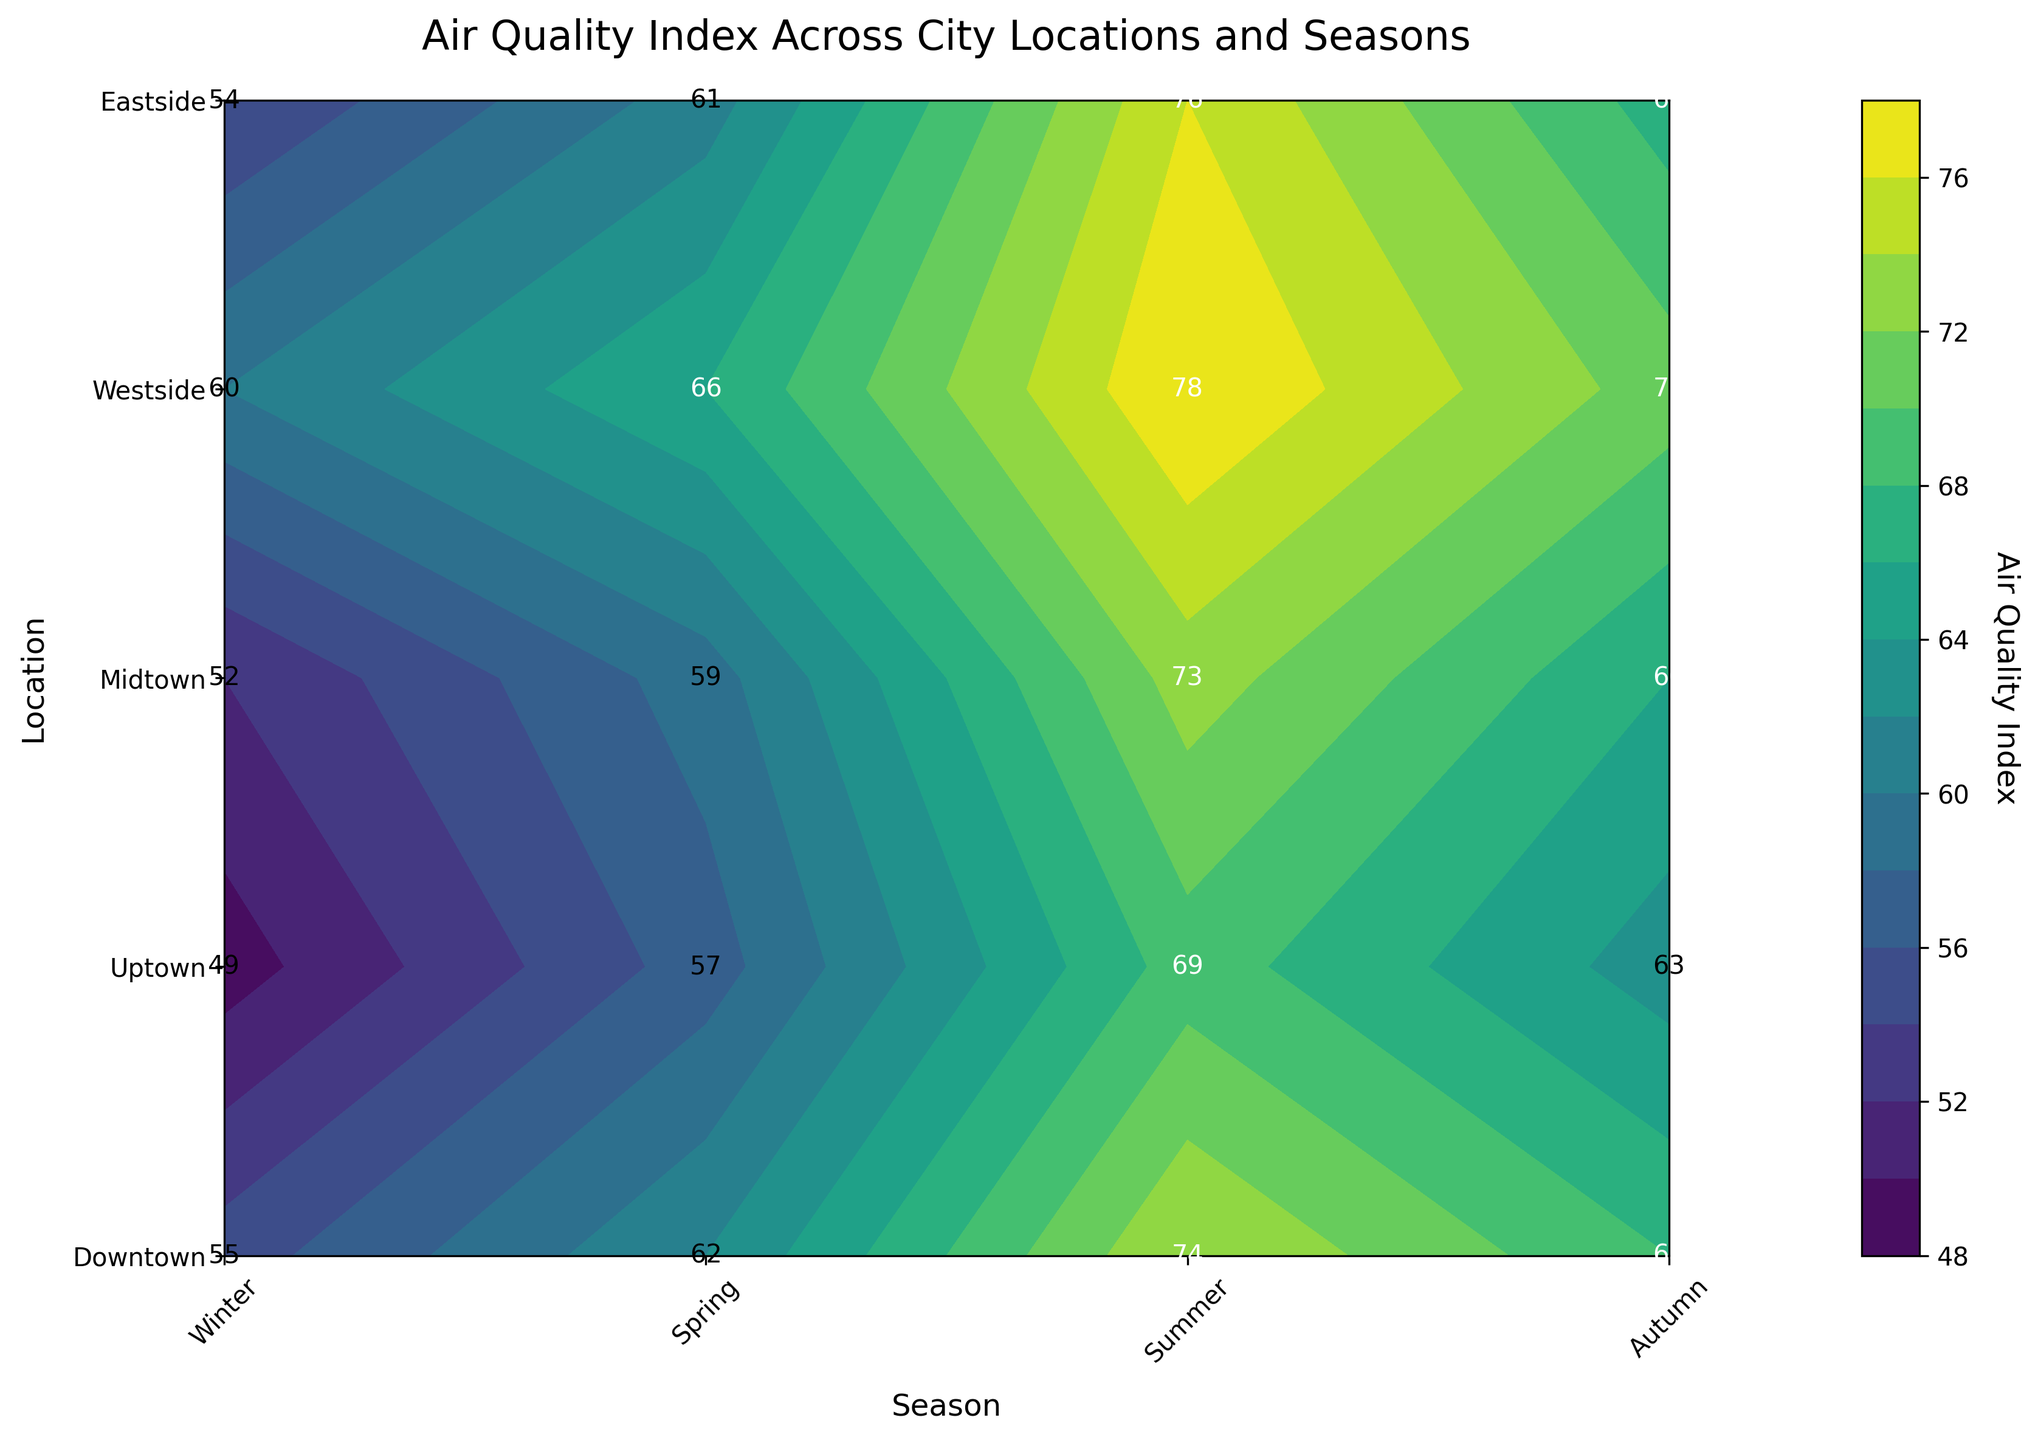What's the title of the plot? The title of the plot is displayed at the top center of the figure. It summarizes what the plot is about.
Answer: Air Quality Index Across City Locations and Seasons What does the y-axis represent? The y-axis labels indicate different parts of the city, so it represents various city locations.
Answer: Various city locations Which season has the highest AQI in Downtown? The AQI values are labeled within the contour plot. By scanning the values for Downtown, we find the highest value.
Answer: Summer What's the color range in the contour plot? The color range can be seen by looking at the gradient of colors used in the contour plot and the color bar on the side. It shows the range of AQIs.
Answer: From dark blue (lowest AQI) to yellow-green (highest AQI) What is the AQI difference between Winter and Summer in Westside? Locate the AQI values for Winter and Summer in Westside. Subtract the Winter value from the Summer value to get the difference.
Answer: 18 (78 - 60) Which location has the lowest AQI in Autumn? Check the AQI values for all locations in Autumn and find the one with the lowest value.
Answer: Uptown During which season does Eastside experience the maximum AQI? Observe the AQI values for Eastside across all seasons and identify the maximum value.
Answer: Summer In which location and season is the AQI value 57? Scan through all locations and seasons, looking for the AQI value of 57.
Answer: Uptown in Spring Compare the AQI in Midtown during Winter and Autumn. Which season has a higher AQI? Check the AQI values for Midtown in Winter and Autumn and compare them.
Answer: Autumn (66 > 52) What is the average AQI across all seasons for Westside? Sum the AQI values for Westside across all seasons and divide by the number of seasons (4). The values are 60, 66, 78, and 71. Sum equals 275, and average is 275/4.
Answer: 68.75 